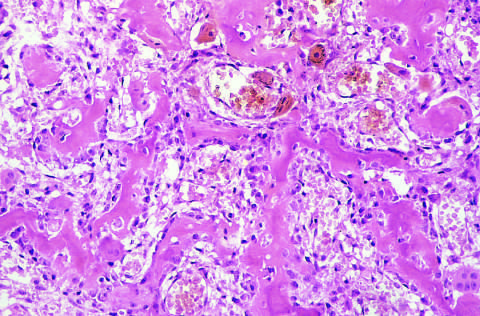s renal glomerulus composed of haphazardly interconnecting trabeculae of woven bone that are rimmed by prominent osteoblasts?
Answer the question using a single word or phrase. No 